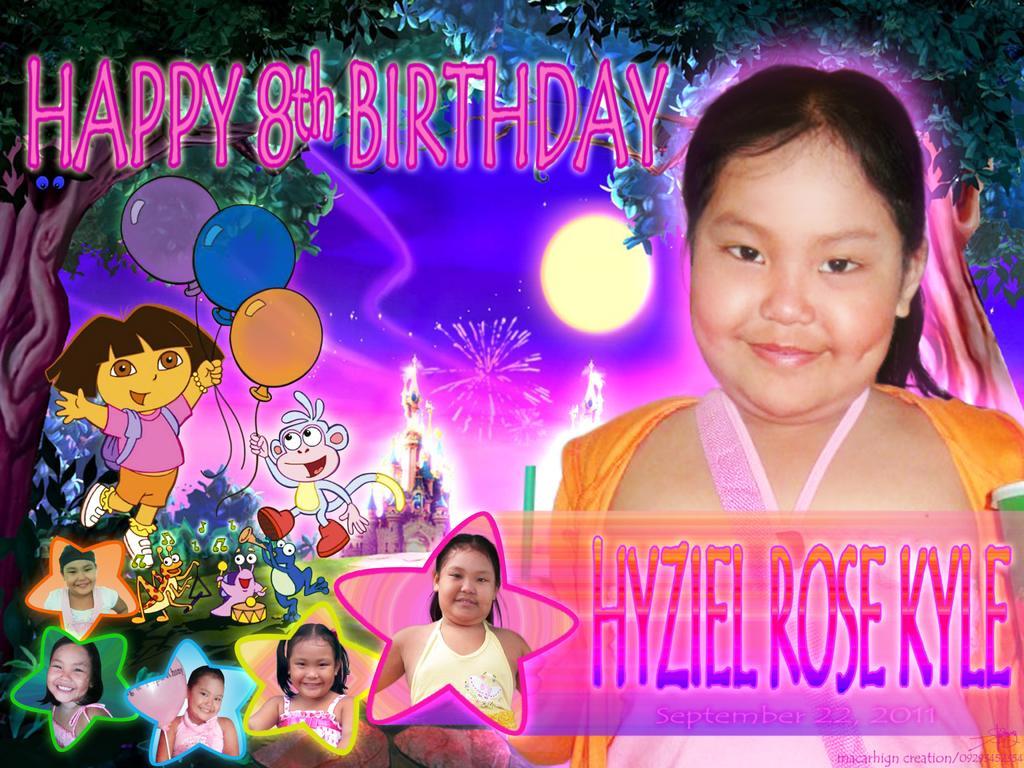Describe this image in one or two sentences. In this image it looks like it is the birthday greeting card. There is a girl on the right side. On the left side there are animation images. It looks like a birthday poster. 